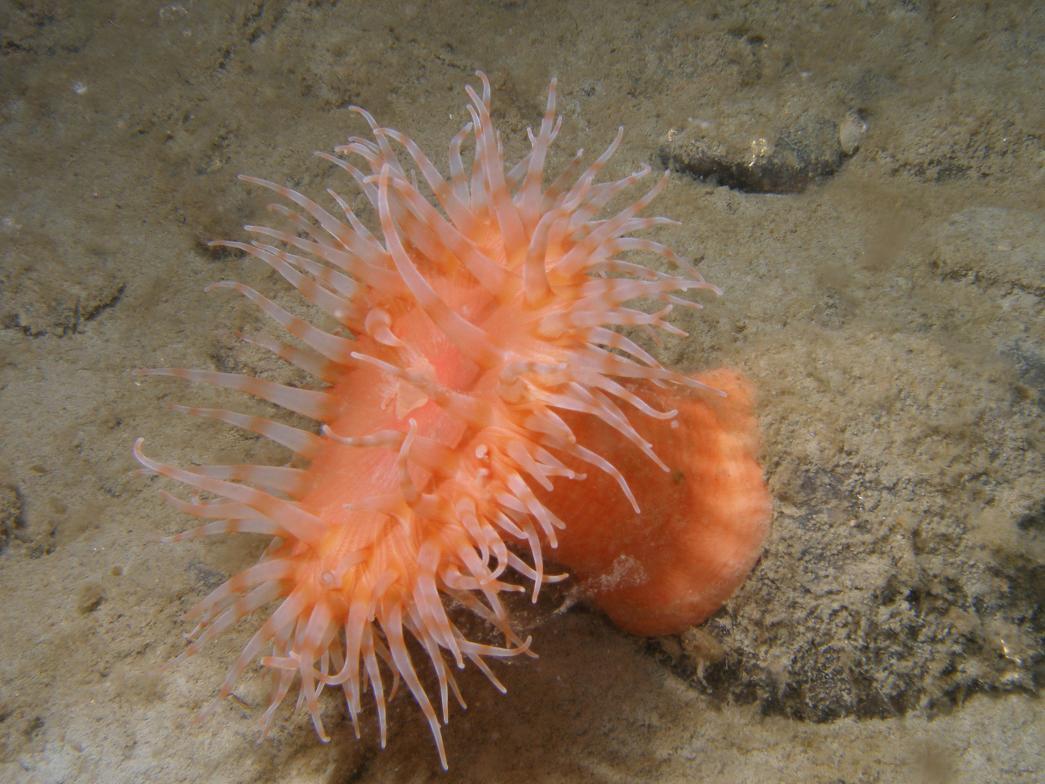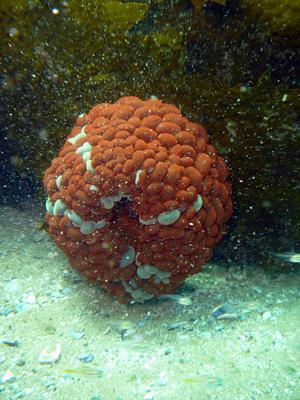The first image is the image on the left, the second image is the image on the right. Examine the images to the left and right. Is the description "In one image in each pair there is a starfish to the left of an anenome." accurate? Answer yes or no. No. The first image is the image on the left, the second image is the image on the right. Given the left and right images, does the statement "The anemone in the left image is orange." hold true? Answer yes or no. Yes. 